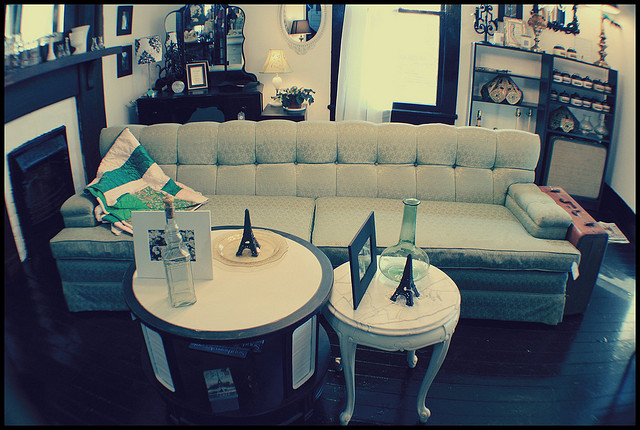<image>What vegetable does the sculpture on the right resemble? I don't know. There may not be any specific vegetable resemblance in the sculpture. However, it can be a gourd or lettuce or asparagus. What vegetable does the sculpture on the right resemble? I don't know what vegetable the sculpture on the right resembles. It can be seen as 'gourd' or 'asparagus'. 